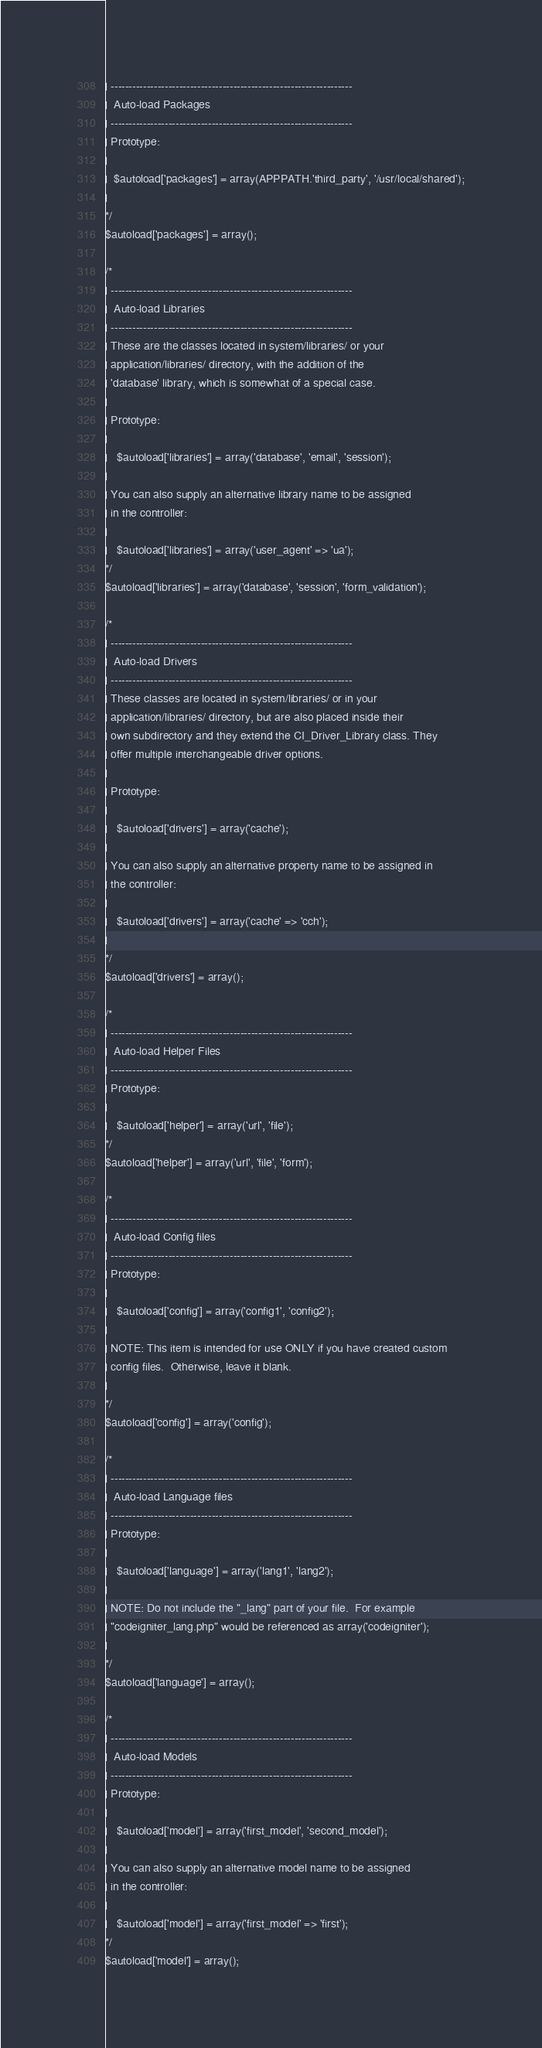Convert code to text. <code><loc_0><loc_0><loc_500><loc_500><_PHP_>| -------------------------------------------------------------------
|  Auto-load Packages
| -------------------------------------------------------------------
| Prototype:
|
|  $autoload['packages'] = array(APPPATH.'third_party', '/usr/local/shared');
|
*/
$autoload['packages'] = array();

/*
| -------------------------------------------------------------------
|  Auto-load Libraries
| -------------------------------------------------------------------
| These are the classes located in system/libraries/ or your
| application/libraries/ directory, with the addition of the
| 'database' library, which is somewhat of a special case.
|
| Prototype:
|
|	$autoload['libraries'] = array('database', 'email', 'session');
|
| You can also supply an alternative library name to be assigned
| in the controller:
|
|	$autoload['libraries'] = array('user_agent' => 'ua');
*/
$autoload['libraries'] = array('database', 'session', 'form_validation');

/*
| -------------------------------------------------------------------
|  Auto-load Drivers
| -------------------------------------------------------------------
| These classes are located in system/libraries/ or in your
| application/libraries/ directory, but are also placed inside their
| own subdirectory and they extend the CI_Driver_Library class. They
| offer multiple interchangeable driver options.
|
| Prototype:
|
|	$autoload['drivers'] = array('cache');
|
| You can also supply an alternative property name to be assigned in
| the controller:
|
|	$autoload['drivers'] = array('cache' => 'cch');
|
*/
$autoload['drivers'] = array();

/*
| -------------------------------------------------------------------
|  Auto-load Helper Files
| -------------------------------------------------------------------
| Prototype:
|
|	$autoload['helper'] = array('url', 'file');
*/
$autoload['helper'] = array('url', 'file', 'form');

/*
| -------------------------------------------------------------------
|  Auto-load Config files
| -------------------------------------------------------------------
| Prototype:
|
|	$autoload['config'] = array('config1', 'config2');
|
| NOTE: This item is intended for use ONLY if you have created custom
| config files.  Otherwise, leave it blank.
|
*/
$autoload['config'] = array('config');

/*
| -------------------------------------------------------------------
|  Auto-load Language files
| -------------------------------------------------------------------
| Prototype:
|
|	$autoload['language'] = array('lang1', 'lang2');
|
| NOTE: Do not include the "_lang" part of your file.  For example
| "codeigniter_lang.php" would be referenced as array('codeigniter');
|
*/
$autoload['language'] = array();

/*
| -------------------------------------------------------------------
|  Auto-load Models
| -------------------------------------------------------------------
| Prototype:
|
|	$autoload['model'] = array('first_model', 'second_model');
|
| You can also supply an alternative model name to be assigned
| in the controller:
|
|	$autoload['model'] = array('first_model' => 'first');
*/
$autoload['model'] = array();
</code> 